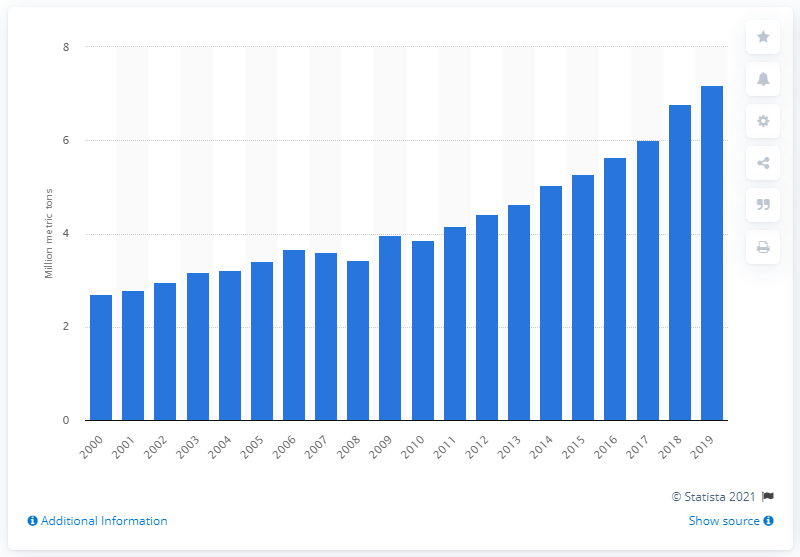Give some essential details in this illustration. In 2019, the global production of avocados was 7.18 million. The previous year's production volume of avocados was 6.77... 